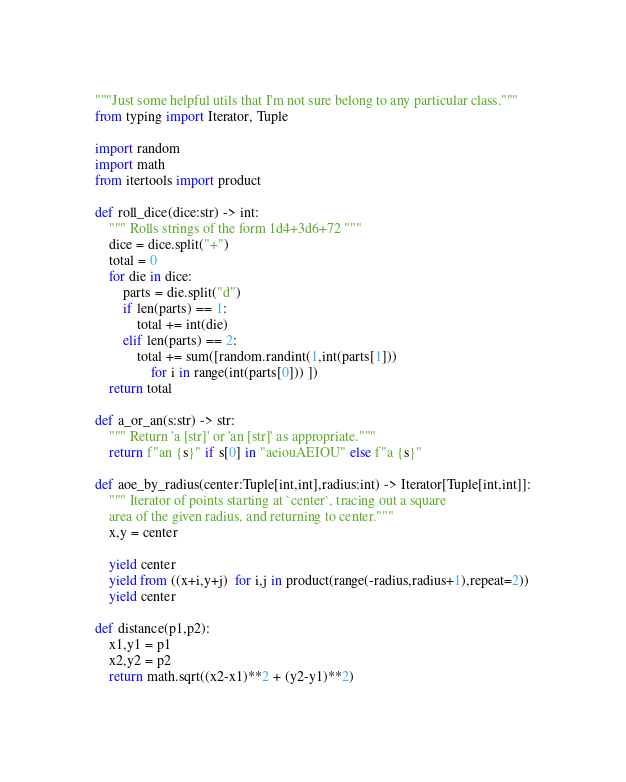Convert code to text. <code><loc_0><loc_0><loc_500><loc_500><_Python_>"""Just some helpful utils that I'm not sure belong to any particular class."""
from typing import Iterator, Tuple

import random
import math
from itertools import product

def roll_dice(dice:str) -> int:
    """ Rolls strings of the form 1d4+3d6+72 """
    dice = dice.split("+")
    total = 0
    for die in dice:
        parts = die.split("d")
        if len(parts) == 1:
            total += int(die)
        elif len(parts) == 2:
            total += sum([random.randint(1,int(parts[1])) 
                for i in range(int(parts[0])) ])
    return total

def a_or_an(s:str) -> str:
    """ Return 'a [str]' or 'an [str]' as appropriate."""
    return f"an {s}" if s[0] in "aeiouAEIOU" else f"a {s}"

def aoe_by_radius(center:Tuple[int,int],radius:int) -> Iterator[Tuple[int,int]]:
    """ Iterator of points starting at `center`, tracing out a square
    area of the given radius, and returning to center."""
    x,y = center

    yield center
    yield from ((x+i,y+j)  for i,j in product(range(-radius,radius+1),repeat=2))
    yield center

def distance(p1,p2):
    x1,y1 = p1
    x2,y2 = p2
    return math.sqrt((x2-x1)**2 + (y2-y1)**2)
</code> 